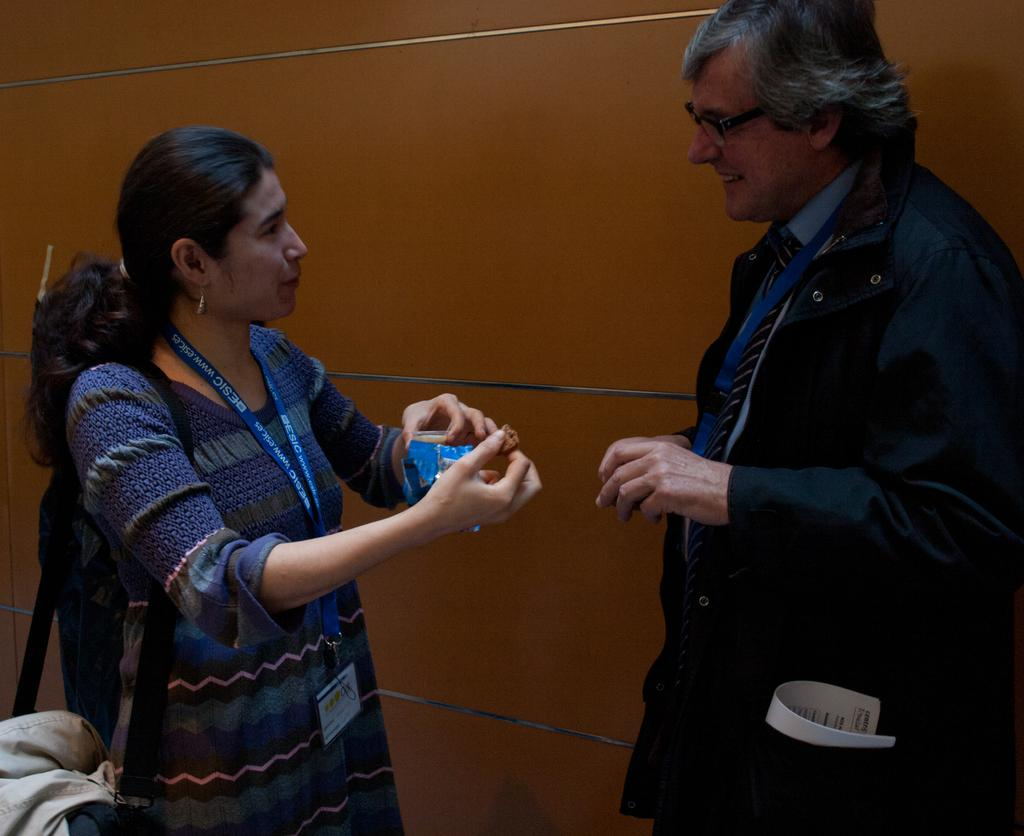What is the gender of the person on the right side of the image? There is a man on the right side of the image. What is the man wearing in the image? The man is wearing a jacket, shirt, and tie. What is the gender of the person on the left side of the image? There is a woman on the left side of the image. What is the woman wearing in the image? The woman is wearing a dress, a tag, and a handbag. What can be seen in the background of the image? There is a wall in the background of the image. How many doors are visible in the image? There are no doors visible in the image. What type of currency is being used by the mice in the image? There are no mice present in the image, so it is not possible to determine what type of currency they might be using. 